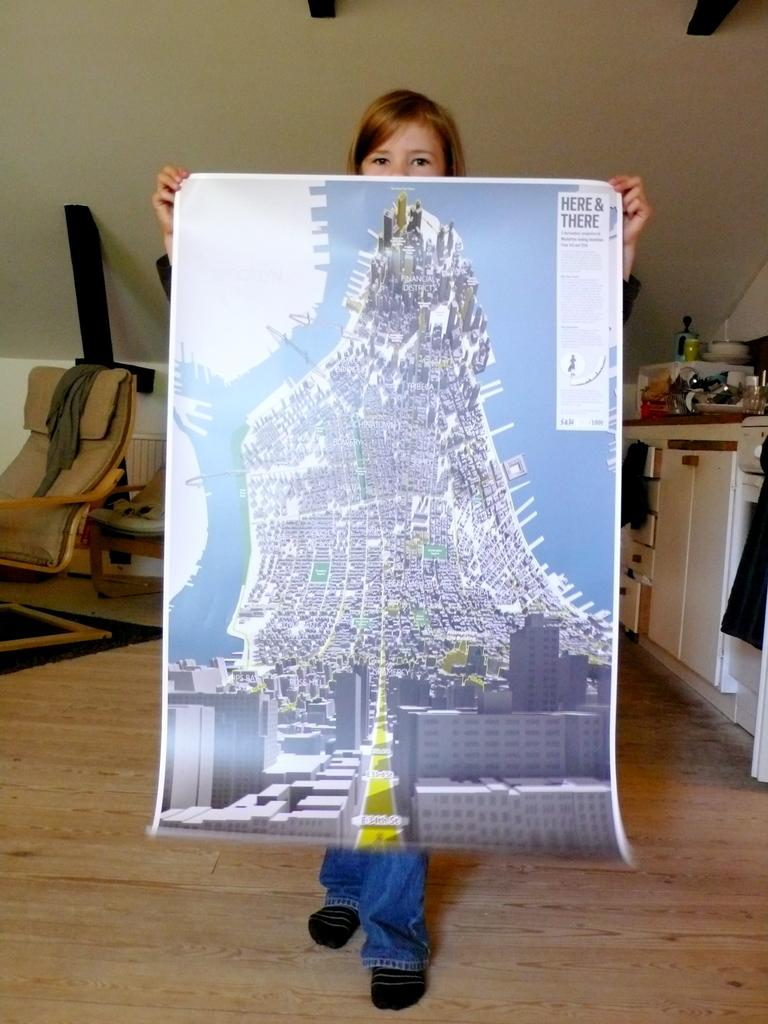Who is the main subject in the image? There is a girl in the image. What is the girl holding in the image? The girl is holding a photo. What can be seen in the background of the image? There is a chair and few stuffs in the background of the image. What type of skirt is the girl wearing in the image? The provided facts do not mention the girl's clothing, so we cannot determine if she is wearing a skirt or any other type of clothing. --- Facts: 1. There is a car in the image. 2. The car is parked on the street. 3. There are trees on both sides of the street. 4. The sky is visible in the image. Absurd Topics: bird, nest, fly Conversation: What is the main subject in the image? There is a car in the image. Where is the car located in the image? The car is parked on the street. What can be seen on both sides of the street in the image? There are trees on both sides of the street. What is visible in the background of the image? The sky is visible in the image. Reasoning: Let's think step by step in order to produce the conversation. We start by identifying the main subject in the image, which is the car. Then, we describe the car's location, which is parked on the street. Next, we mention the trees on both sides of the street, which provide context for the setting. Finally, we acknowledge the presence of the sky in the background. Each question is designed to elicit a specific detail about the image that is known from the provided facts. Absurd Question/Answer: Can you see a bird's nest in the car's engine in the image? There is no mention of a bird's nest or any bird-related elements in the image, so we cannot determine if one is present in the car's engine. 